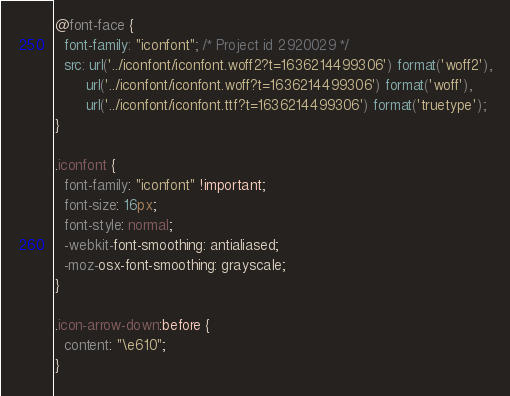Convert code to text. <code><loc_0><loc_0><loc_500><loc_500><_CSS_>@font-face {
  font-family: "iconfont"; /* Project id 2920029 */
  src: url('../iconfont/iconfont.woff2?t=1636214499306') format('woff2'),
       url('../iconfont/iconfont.woff?t=1636214499306') format('woff'),
       url('../iconfont/iconfont.ttf?t=1636214499306') format('truetype');
}

.iconfont {
  font-family: "iconfont" !important;
  font-size: 16px;
  font-style: normal;
  -webkit-font-smoothing: antialiased;
  -moz-osx-font-smoothing: grayscale;
}

.icon-arrow-down:before {
  content: "\e610";
}

</code> 